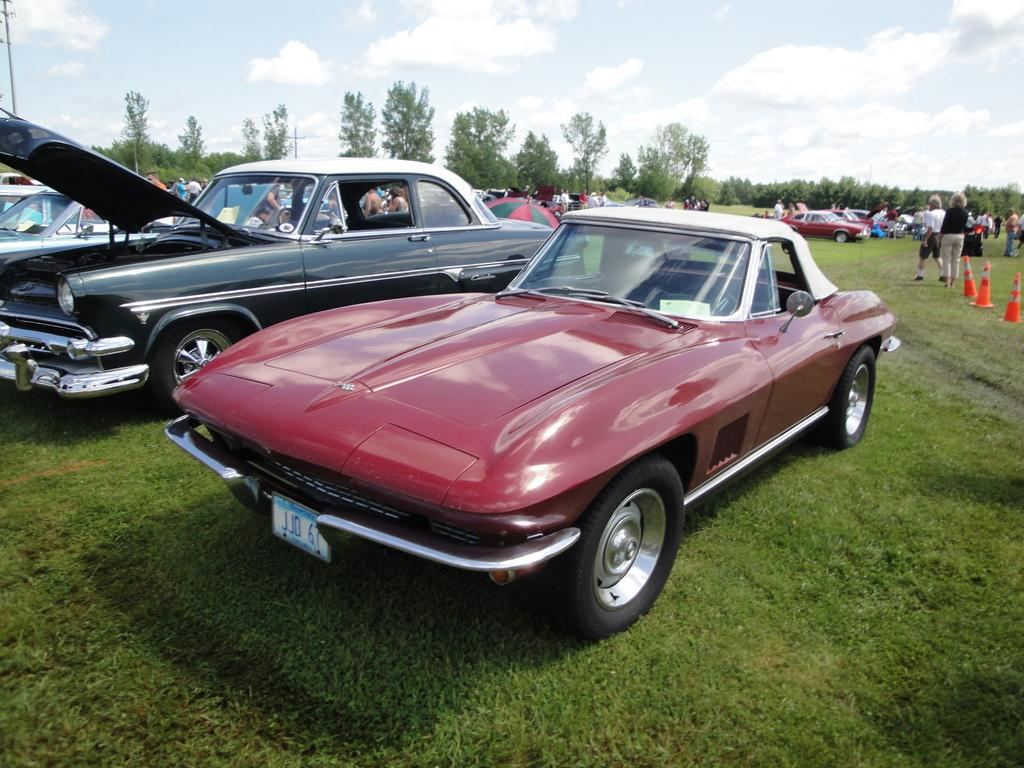What is located on the grass in the center of the image? There are cars on the grass in the center of the image. What can be seen in the background of the image? In the background, there are traffic cones, persons, cars, trees, poles, and the sky. Can you describe the sky in the image? The sky is visible in the background, and clouds are present in the sky. What type of bun is being used to fuel the cars in the image? There is no bun present in the image, and cars are not fueled by buns. How much coal is visible in the image? There is no coal present in the image. 